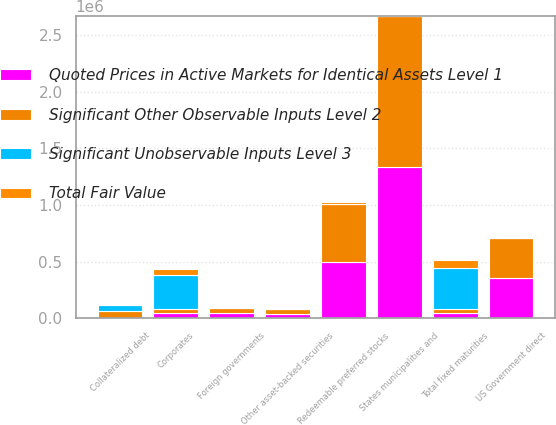Convert chart. <chart><loc_0><loc_0><loc_500><loc_500><stacked_bar_chart><ecel><fcel>US Government direct<fcel>States municipalities and<fcel>Foreign governments<fcel>Corporates<fcel>Collateralized debt<fcel>Other asset-backed securities<fcel>Redeemable preferred stocks<fcel>Total fixed maturities<nl><fcel>Total Fair Value<fcel>0<fcel>0<fcel>0<fcel>47058<fcel>0<fcel>0<fcel>22220<fcel>69278<nl><fcel>Quoted Prices in Active Markets for Identical Assets Level 1<fcel>353173<fcel>1.3353e+06<fcel>44155<fcel>41162<fcel>0<fcel>38169<fcel>491561<fcel>41162<nl><fcel>Significant Unobservable Inputs Level 3<fcel>0<fcel>0<fcel>0<fcel>300300<fcel>58205<fcel>0<fcel>0<fcel>358505<nl><fcel>Significant Other Observable Inputs Level 2<fcel>353173<fcel>1.3353e+06<fcel>44155<fcel>41162<fcel>58205<fcel>38169<fcel>513781<fcel>41162<nl></chart> 